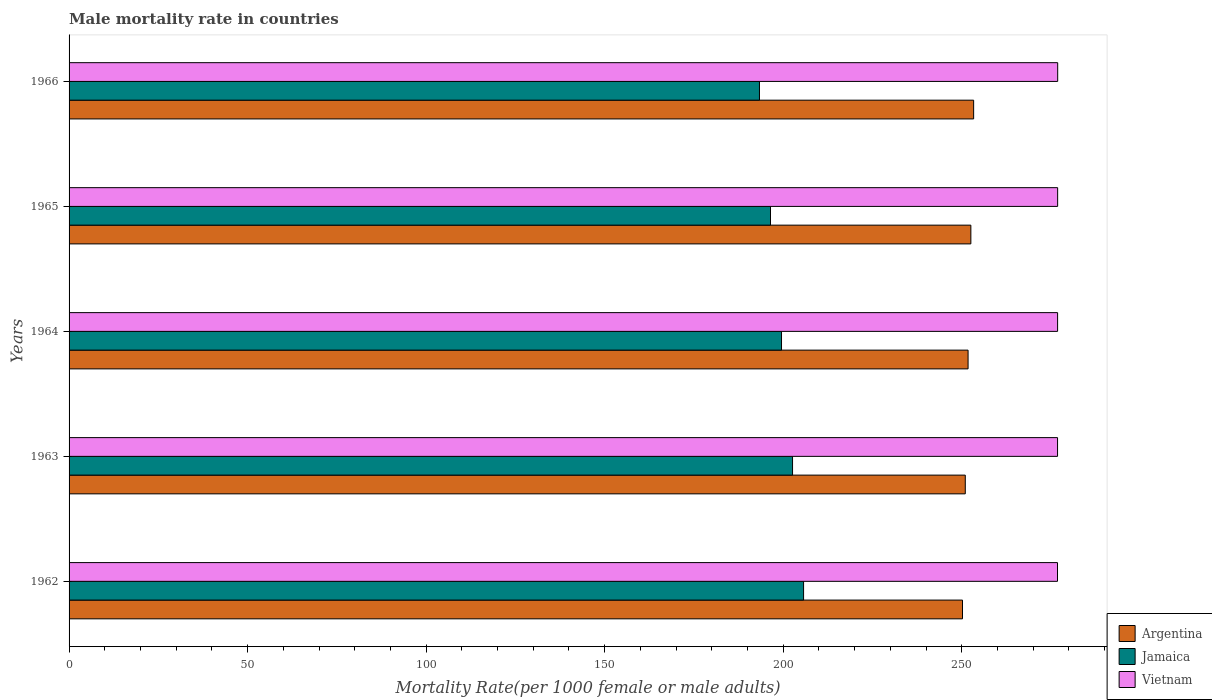Are the number of bars on each tick of the Y-axis equal?
Provide a succinct answer. Yes. How many bars are there on the 3rd tick from the top?
Make the answer very short. 3. In how many cases, is the number of bars for a given year not equal to the number of legend labels?
Your response must be concise. 0. What is the male mortality rate in Vietnam in 1966?
Offer a terse response. 276.88. Across all years, what is the maximum male mortality rate in Vietnam?
Give a very brief answer. 276.88. Across all years, what is the minimum male mortality rate in Argentina?
Ensure brevity in your answer.  250.22. In which year was the male mortality rate in Vietnam maximum?
Make the answer very short. 1966. In which year was the male mortality rate in Argentina minimum?
Keep it short and to the point. 1962. What is the total male mortality rate in Vietnam in the graph?
Offer a very short reply. 1384.25. What is the difference between the male mortality rate in Vietnam in 1962 and that in 1963?
Your answer should be compact. -0.01. What is the difference between the male mortality rate in Vietnam in 1962 and the male mortality rate in Argentina in 1963?
Provide a succinct answer. 25.83. What is the average male mortality rate in Vietnam per year?
Give a very brief answer. 276.85. In the year 1966, what is the difference between the male mortality rate in Jamaica and male mortality rate in Argentina?
Give a very brief answer. -59.98. What is the ratio of the male mortality rate in Argentina in 1963 to that in 1964?
Ensure brevity in your answer.  1. Is the difference between the male mortality rate in Jamaica in 1964 and 1966 greater than the difference between the male mortality rate in Argentina in 1964 and 1966?
Ensure brevity in your answer.  Yes. What is the difference between the highest and the second highest male mortality rate in Vietnam?
Ensure brevity in your answer.  0.01. What is the difference between the highest and the lowest male mortality rate in Jamaica?
Your answer should be compact. 12.35. In how many years, is the male mortality rate in Vietnam greater than the average male mortality rate in Vietnam taken over all years?
Provide a succinct answer. 2. What does the 2nd bar from the top in 1963 represents?
Keep it short and to the point. Jamaica. What does the 2nd bar from the bottom in 1962 represents?
Provide a short and direct response. Jamaica. Are all the bars in the graph horizontal?
Your answer should be very brief. Yes. How many years are there in the graph?
Make the answer very short. 5. What is the difference between two consecutive major ticks on the X-axis?
Offer a terse response. 50. Are the values on the major ticks of X-axis written in scientific E-notation?
Offer a terse response. No. Does the graph contain any zero values?
Your response must be concise. No. Where does the legend appear in the graph?
Keep it short and to the point. Bottom right. What is the title of the graph?
Keep it short and to the point. Male mortality rate in countries. What is the label or title of the X-axis?
Make the answer very short. Mortality Rate(per 1000 female or male adults). What is the label or title of the Y-axis?
Your response must be concise. Years. What is the Mortality Rate(per 1000 female or male adults) in Argentina in 1962?
Keep it short and to the point. 250.22. What is the Mortality Rate(per 1000 female or male adults) in Jamaica in 1962?
Your answer should be very brief. 205.71. What is the Mortality Rate(per 1000 female or male adults) of Vietnam in 1962?
Offer a terse response. 276.82. What is the Mortality Rate(per 1000 female or male adults) in Argentina in 1963?
Offer a terse response. 251. What is the Mortality Rate(per 1000 female or male adults) of Jamaica in 1963?
Keep it short and to the point. 202.62. What is the Mortality Rate(per 1000 female or male adults) in Vietnam in 1963?
Keep it short and to the point. 276.84. What is the Mortality Rate(per 1000 female or male adults) of Argentina in 1964?
Offer a very short reply. 251.78. What is the Mortality Rate(per 1000 female or male adults) of Jamaica in 1964?
Give a very brief answer. 199.53. What is the Mortality Rate(per 1000 female or male adults) in Vietnam in 1964?
Your answer should be compact. 276.85. What is the Mortality Rate(per 1000 female or male adults) in Argentina in 1965?
Ensure brevity in your answer.  252.56. What is the Mortality Rate(per 1000 female or male adults) in Jamaica in 1965?
Provide a succinct answer. 196.44. What is the Mortality Rate(per 1000 female or male adults) in Vietnam in 1965?
Give a very brief answer. 276.86. What is the Mortality Rate(per 1000 female or male adults) in Argentina in 1966?
Your answer should be compact. 253.34. What is the Mortality Rate(per 1000 female or male adults) in Jamaica in 1966?
Make the answer very short. 193.36. What is the Mortality Rate(per 1000 female or male adults) in Vietnam in 1966?
Offer a very short reply. 276.88. Across all years, what is the maximum Mortality Rate(per 1000 female or male adults) of Argentina?
Make the answer very short. 253.34. Across all years, what is the maximum Mortality Rate(per 1000 female or male adults) of Jamaica?
Your answer should be compact. 205.71. Across all years, what is the maximum Mortality Rate(per 1000 female or male adults) of Vietnam?
Your response must be concise. 276.88. Across all years, what is the minimum Mortality Rate(per 1000 female or male adults) in Argentina?
Make the answer very short. 250.22. Across all years, what is the minimum Mortality Rate(per 1000 female or male adults) in Jamaica?
Offer a terse response. 193.36. Across all years, what is the minimum Mortality Rate(per 1000 female or male adults) in Vietnam?
Make the answer very short. 276.82. What is the total Mortality Rate(per 1000 female or male adults) of Argentina in the graph?
Your response must be concise. 1258.89. What is the total Mortality Rate(per 1000 female or male adults) in Jamaica in the graph?
Your response must be concise. 997.66. What is the total Mortality Rate(per 1000 female or male adults) in Vietnam in the graph?
Make the answer very short. 1384.25. What is the difference between the Mortality Rate(per 1000 female or male adults) of Argentina in 1962 and that in 1963?
Give a very brief answer. -0.78. What is the difference between the Mortality Rate(per 1000 female or male adults) in Jamaica in 1962 and that in 1963?
Keep it short and to the point. 3.09. What is the difference between the Mortality Rate(per 1000 female or male adults) of Vietnam in 1962 and that in 1963?
Offer a very short reply. -0.01. What is the difference between the Mortality Rate(per 1000 female or male adults) in Argentina in 1962 and that in 1964?
Offer a very short reply. -1.56. What is the difference between the Mortality Rate(per 1000 female or male adults) in Jamaica in 1962 and that in 1964?
Your answer should be very brief. 6.18. What is the difference between the Mortality Rate(per 1000 female or male adults) of Vietnam in 1962 and that in 1964?
Keep it short and to the point. -0.03. What is the difference between the Mortality Rate(per 1000 female or male adults) in Argentina in 1962 and that in 1965?
Provide a succinct answer. -2.34. What is the difference between the Mortality Rate(per 1000 female or male adults) of Jamaica in 1962 and that in 1965?
Offer a very short reply. 9.27. What is the difference between the Mortality Rate(per 1000 female or male adults) in Vietnam in 1962 and that in 1965?
Make the answer very short. -0.04. What is the difference between the Mortality Rate(per 1000 female or male adults) in Argentina in 1962 and that in 1966?
Provide a succinct answer. -3.12. What is the difference between the Mortality Rate(per 1000 female or male adults) of Jamaica in 1962 and that in 1966?
Offer a terse response. 12.35. What is the difference between the Mortality Rate(per 1000 female or male adults) in Vietnam in 1962 and that in 1966?
Offer a terse response. -0.05. What is the difference between the Mortality Rate(per 1000 female or male adults) in Argentina in 1963 and that in 1964?
Keep it short and to the point. -0.78. What is the difference between the Mortality Rate(per 1000 female or male adults) in Jamaica in 1963 and that in 1964?
Provide a short and direct response. 3.09. What is the difference between the Mortality Rate(per 1000 female or male adults) of Vietnam in 1963 and that in 1964?
Your answer should be very brief. -0.01. What is the difference between the Mortality Rate(per 1000 female or male adults) in Argentina in 1963 and that in 1965?
Offer a terse response. -1.56. What is the difference between the Mortality Rate(per 1000 female or male adults) of Jamaica in 1963 and that in 1965?
Make the answer very short. 6.18. What is the difference between the Mortality Rate(per 1000 female or male adults) in Vietnam in 1963 and that in 1965?
Offer a very short reply. -0.03. What is the difference between the Mortality Rate(per 1000 female or male adults) in Argentina in 1963 and that in 1966?
Your answer should be very brief. -2.34. What is the difference between the Mortality Rate(per 1000 female or male adults) of Jamaica in 1963 and that in 1966?
Give a very brief answer. 9.27. What is the difference between the Mortality Rate(per 1000 female or male adults) of Vietnam in 1963 and that in 1966?
Make the answer very short. -0.04. What is the difference between the Mortality Rate(per 1000 female or male adults) in Argentina in 1964 and that in 1965?
Make the answer very short. -0.78. What is the difference between the Mortality Rate(per 1000 female or male adults) of Jamaica in 1964 and that in 1965?
Your response must be concise. 3.09. What is the difference between the Mortality Rate(per 1000 female or male adults) in Vietnam in 1964 and that in 1965?
Your answer should be compact. -0.01. What is the difference between the Mortality Rate(per 1000 female or male adults) in Argentina in 1964 and that in 1966?
Keep it short and to the point. -1.56. What is the difference between the Mortality Rate(per 1000 female or male adults) of Jamaica in 1964 and that in 1966?
Your response must be concise. 6.18. What is the difference between the Mortality Rate(per 1000 female or male adults) in Vietnam in 1964 and that in 1966?
Your response must be concise. -0.03. What is the difference between the Mortality Rate(per 1000 female or male adults) in Argentina in 1965 and that in 1966?
Provide a succinct answer. -0.78. What is the difference between the Mortality Rate(per 1000 female or male adults) of Jamaica in 1965 and that in 1966?
Your answer should be compact. 3.09. What is the difference between the Mortality Rate(per 1000 female or male adults) in Vietnam in 1965 and that in 1966?
Offer a terse response. -0.01. What is the difference between the Mortality Rate(per 1000 female or male adults) of Argentina in 1962 and the Mortality Rate(per 1000 female or male adults) of Jamaica in 1963?
Your answer should be very brief. 47.6. What is the difference between the Mortality Rate(per 1000 female or male adults) in Argentina in 1962 and the Mortality Rate(per 1000 female or male adults) in Vietnam in 1963?
Your answer should be very brief. -26.62. What is the difference between the Mortality Rate(per 1000 female or male adults) in Jamaica in 1962 and the Mortality Rate(per 1000 female or male adults) in Vietnam in 1963?
Your answer should be very brief. -71.13. What is the difference between the Mortality Rate(per 1000 female or male adults) of Argentina in 1962 and the Mortality Rate(per 1000 female or male adults) of Jamaica in 1964?
Your answer should be very brief. 50.69. What is the difference between the Mortality Rate(per 1000 female or male adults) in Argentina in 1962 and the Mortality Rate(per 1000 female or male adults) in Vietnam in 1964?
Ensure brevity in your answer.  -26.63. What is the difference between the Mortality Rate(per 1000 female or male adults) in Jamaica in 1962 and the Mortality Rate(per 1000 female or male adults) in Vietnam in 1964?
Make the answer very short. -71.14. What is the difference between the Mortality Rate(per 1000 female or male adults) of Argentina in 1962 and the Mortality Rate(per 1000 female or male adults) of Jamaica in 1965?
Your answer should be compact. 53.78. What is the difference between the Mortality Rate(per 1000 female or male adults) of Argentina in 1962 and the Mortality Rate(per 1000 female or male adults) of Vietnam in 1965?
Offer a very short reply. -26.64. What is the difference between the Mortality Rate(per 1000 female or male adults) of Jamaica in 1962 and the Mortality Rate(per 1000 female or male adults) of Vietnam in 1965?
Ensure brevity in your answer.  -71.15. What is the difference between the Mortality Rate(per 1000 female or male adults) in Argentina in 1962 and the Mortality Rate(per 1000 female or male adults) in Jamaica in 1966?
Make the answer very short. 56.86. What is the difference between the Mortality Rate(per 1000 female or male adults) in Argentina in 1962 and the Mortality Rate(per 1000 female or male adults) in Vietnam in 1966?
Provide a succinct answer. -26.66. What is the difference between the Mortality Rate(per 1000 female or male adults) of Jamaica in 1962 and the Mortality Rate(per 1000 female or male adults) of Vietnam in 1966?
Offer a terse response. -71.17. What is the difference between the Mortality Rate(per 1000 female or male adults) in Argentina in 1963 and the Mortality Rate(per 1000 female or male adults) in Jamaica in 1964?
Provide a succinct answer. 51.47. What is the difference between the Mortality Rate(per 1000 female or male adults) of Argentina in 1963 and the Mortality Rate(per 1000 female or male adults) of Vietnam in 1964?
Your response must be concise. -25.85. What is the difference between the Mortality Rate(per 1000 female or male adults) of Jamaica in 1963 and the Mortality Rate(per 1000 female or male adults) of Vietnam in 1964?
Offer a very short reply. -74.23. What is the difference between the Mortality Rate(per 1000 female or male adults) of Argentina in 1963 and the Mortality Rate(per 1000 female or male adults) of Jamaica in 1965?
Make the answer very short. 54.55. What is the difference between the Mortality Rate(per 1000 female or male adults) of Argentina in 1963 and the Mortality Rate(per 1000 female or male adults) of Vietnam in 1965?
Provide a succinct answer. -25.86. What is the difference between the Mortality Rate(per 1000 female or male adults) of Jamaica in 1963 and the Mortality Rate(per 1000 female or male adults) of Vietnam in 1965?
Provide a succinct answer. -74.24. What is the difference between the Mortality Rate(per 1000 female or male adults) of Argentina in 1963 and the Mortality Rate(per 1000 female or male adults) of Jamaica in 1966?
Your answer should be compact. 57.64. What is the difference between the Mortality Rate(per 1000 female or male adults) of Argentina in 1963 and the Mortality Rate(per 1000 female or male adults) of Vietnam in 1966?
Keep it short and to the point. -25.88. What is the difference between the Mortality Rate(per 1000 female or male adults) in Jamaica in 1963 and the Mortality Rate(per 1000 female or male adults) in Vietnam in 1966?
Give a very brief answer. -74.26. What is the difference between the Mortality Rate(per 1000 female or male adults) of Argentina in 1964 and the Mortality Rate(per 1000 female or male adults) of Jamaica in 1965?
Your response must be concise. 55.33. What is the difference between the Mortality Rate(per 1000 female or male adults) in Argentina in 1964 and the Mortality Rate(per 1000 female or male adults) in Vietnam in 1965?
Offer a very short reply. -25.09. What is the difference between the Mortality Rate(per 1000 female or male adults) of Jamaica in 1964 and the Mortality Rate(per 1000 female or male adults) of Vietnam in 1965?
Your answer should be very brief. -77.33. What is the difference between the Mortality Rate(per 1000 female or male adults) of Argentina in 1964 and the Mortality Rate(per 1000 female or male adults) of Jamaica in 1966?
Your response must be concise. 58.42. What is the difference between the Mortality Rate(per 1000 female or male adults) of Argentina in 1964 and the Mortality Rate(per 1000 female or male adults) of Vietnam in 1966?
Your response must be concise. -25.1. What is the difference between the Mortality Rate(per 1000 female or male adults) of Jamaica in 1964 and the Mortality Rate(per 1000 female or male adults) of Vietnam in 1966?
Provide a succinct answer. -77.34. What is the difference between the Mortality Rate(per 1000 female or male adults) of Argentina in 1965 and the Mortality Rate(per 1000 female or male adults) of Jamaica in 1966?
Make the answer very short. 59.2. What is the difference between the Mortality Rate(per 1000 female or male adults) in Argentina in 1965 and the Mortality Rate(per 1000 female or male adults) in Vietnam in 1966?
Keep it short and to the point. -24.32. What is the difference between the Mortality Rate(per 1000 female or male adults) in Jamaica in 1965 and the Mortality Rate(per 1000 female or male adults) in Vietnam in 1966?
Your response must be concise. -80.43. What is the average Mortality Rate(per 1000 female or male adults) in Argentina per year?
Make the answer very short. 251.78. What is the average Mortality Rate(per 1000 female or male adults) of Jamaica per year?
Offer a very short reply. 199.53. What is the average Mortality Rate(per 1000 female or male adults) of Vietnam per year?
Give a very brief answer. 276.85. In the year 1962, what is the difference between the Mortality Rate(per 1000 female or male adults) in Argentina and Mortality Rate(per 1000 female or male adults) in Jamaica?
Keep it short and to the point. 44.51. In the year 1962, what is the difference between the Mortality Rate(per 1000 female or male adults) in Argentina and Mortality Rate(per 1000 female or male adults) in Vietnam?
Ensure brevity in your answer.  -26.61. In the year 1962, what is the difference between the Mortality Rate(per 1000 female or male adults) of Jamaica and Mortality Rate(per 1000 female or male adults) of Vietnam?
Your answer should be compact. -71.11. In the year 1963, what is the difference between the Mortality Rate(per 1000 female or male adults) in Argentina and Mortality Rate(per 1000 female or male adults) in Jamaica?
Offer a very short reply. 48.38. In the year 1963, what is the difference between the Mortality Rate(per 1000 female or male adults) in Argentina and Mortality Rate(per 1000 female or male adults) in Vietnam?
Offer a terse response. -25.84. In the year 1963, what is the difference between the Mortality Rate(per 1000 female or male adults) in Jamaica and Mortality Rate(per 1000 female or male adults) in Vietnam?
Provide a succinct answer. -74.22. In the year 1964, what is the difference between the Mortality Rate(per 1000 female or male adults) in Argentina and Mortality Rate(per 1000 female or male adults) in Jamaica?
Give a very brief answer. 52.25. In the year 1964, what is the difference between the Mortality Rate(per 1000 female or male adults) of Argentina and Mortality Rate(per 1000 female or male adults) of Vietnam?
Keep it short and to the point. -25.07. In the year 1964, what is the difference between the Mortality Rate(per 1000 female or male adults) of Jamaica and Mortality Rate(per 1000 female or male adults) of Vietnam?
Provide a succinct answer. -77.32. In the year 1965, what is the difference between the Mortality Rate(per 1000 female or male adults) in Argentina and Mortality Rate(per 1000 female or male adults) in Jamaica?
Your answer should be very brief. 56.11. In the year 1965, what is the difference between the Mortality Rate(per 1000 female or male adults) of Argentina and Mortality Rate(per 1000 female or male adults) of Vietnam?
Ensure brevity in your answer.  -24.3. In the year 1965, what is the difference between the Mortality Rate(per 1000 female or male adults) in Jamaica and Mortality Rate(per 1000 female or male adults) in Vietnam?
Provide a short and direct response. -80.42. In the year 1966, what is the difference between the Mortality Rate(per 1000 female or male adults) of Argentina and Mortality Rate(per 1000 female or male adults) of Jamaica?
Your answer should be very brief. 59.98. In the year 1966, what is the difference between the Mortality Rate(per 1000 female or male adults) of Argentina and Mortality Rate(per 1000 female or male adults) of Vietnam?
Ensure brevity in your answer.  -23.54. In the year 1966, what is the difference between the Mortality Rate(per 1000 female or male adults) in Jamaica and Mortality Rate(per 1000 female or male adults) in Vietnam?
Offer a very short reply. -83.52. What is the ratio of the Mortality Rate(per 1000 female or male adults) in Argentina in 1962 to that in 1963?
Ensure brevity in your answer.  1. What is the ratio of the Mortality Rate(per 1000 female or male adults) in Jamaica in 1962 to that in 1963?
Offer a very short reply. 1.02. What is the ratio of the Mortality Rate(per 1000 female or male adults) of Jamaica in 1962 to that in 1964?
Make the answer very short. 1.03. What is the ratio of the Mortality Rate(per 1000 female or male adults) of Vietnam in 1962 to that in 1964?
Provide a short and direct response. 1. What is the ratio of the Mortality Rate(per 1000 female or male adults) of Argentina in 1962 to that in 1965?
Make the answer very short. 0.99. What is the ratio of the Mortality Rate(per 1000 female or male adults) in Jamaica in 1962 to that in 1965?
Keep it short and to the point. 1.05. What is the ratio of the Mortality Rate(per 1000 female or male adults) in Vietnam in 1962 to that in 1965?
Give a very brief answer. 1. What is the ratio of the Mortality Rate(per 1000 female or male adults) of Argentina in 1962 to that in 1966?
Offer a very short reply. 0.99. What is the ratio of the Mortality Rate(per 1000 female or male adults) in Jamaica in 1962 to that in 1966?
Your response must be concise. 1.06. What is the ratio of the Mortality Rate(per 1000 female or male adults) of Argentina in 1963 to that in 1964?
Ensure brevity in your answer.  1. What is the ratio of the Mortality Rate(per 1000 female or male adults) of Jamaica in 1963 to that in 1964?
Give a very brief answer. 1.02. What is the ratio of the Mortality Rate(per 1000 female or male adults) in Vietnam in 1963 to that in 1964?
Offer a terse response. 1. What is the ratio of the Mortality Rate(per 1000 female or male adults) in Jamaica in 1963 to that in 1965?
Make the answer very short. 1.03. What is the ratio of the Mortality Rate(per 1000 female or male adults) of Argentina in 1963 to that in 1966?
Your response must be concise. 0.99. What is the ratio of the Mortality Rate(per 1000 female or male adults) in Jamaica in 1963 to that in 1966?
Your response must be concise. 1.05. What is the ratio of the Mortality Rate(per 1000 female or male adults) in Vietnam in 1963 to that in 1966?
Ensure brevity in your answer.  1. What is the ratio of the Mortality Rate(per 1000 female or male adults) in Argentina in 1964 to that in 1965?
Your answer should be compact. 1. What is the ratio of the Mortality Rate(per 1000 female or male adults) of Jamaica in 1964 to that in 1965?
Offer a very short reply. 1.02. What is the ratio of the Mortality Rate(per 1000 female or male adults) in Vietnam in 1964 to that in 1965?
Your response must be concise. 1. What is the ratio of the Mortality Rate(per 1000 female or male adults) in Jamaica in 1964 to that in 1966?
Your answer should be compact. 1.03. What is the ratio of the Mortality Rate(per 1000 female or male adults) of Argentina in 1965 to that in 1966?
Your answer should be compact. 1. What is the ratio of the Mortality Rate(per 1000 female or male adults) of Vietnam in 1965 to that in 1966?
Your answer should be compact. 1. What is the difference between the highest and the second highest Mortality Rate(per 1000 female or male adults) in Argentina?
Your answer should be very brief. 0.78. What is the difference between the highest and the second highest Mortality Rate(per 1000 female or male adults) in Jamaica?
Ensure brevity in your answer.  3.09. What is the difference between the highest and the second highest Mortality Rate(per 1000 female or male adults) in Vietnam?
Offer a terse response. 0.01. What is the difference between the highest and the lowest Mortality Rate(per 1000 female or male adults) of Argentina?
Your answer should be very brief. 3.12. What is the difference between the highest and the lowest Mortality Rate(per 1000 female or male adults) in Jamaica?
Make the answer very short. 12.35. What is the difference between the highest and the lowest Mortality Rate(per 1000 female or male adults) in Vietnam?
Give a very brief answer. 0.05. 